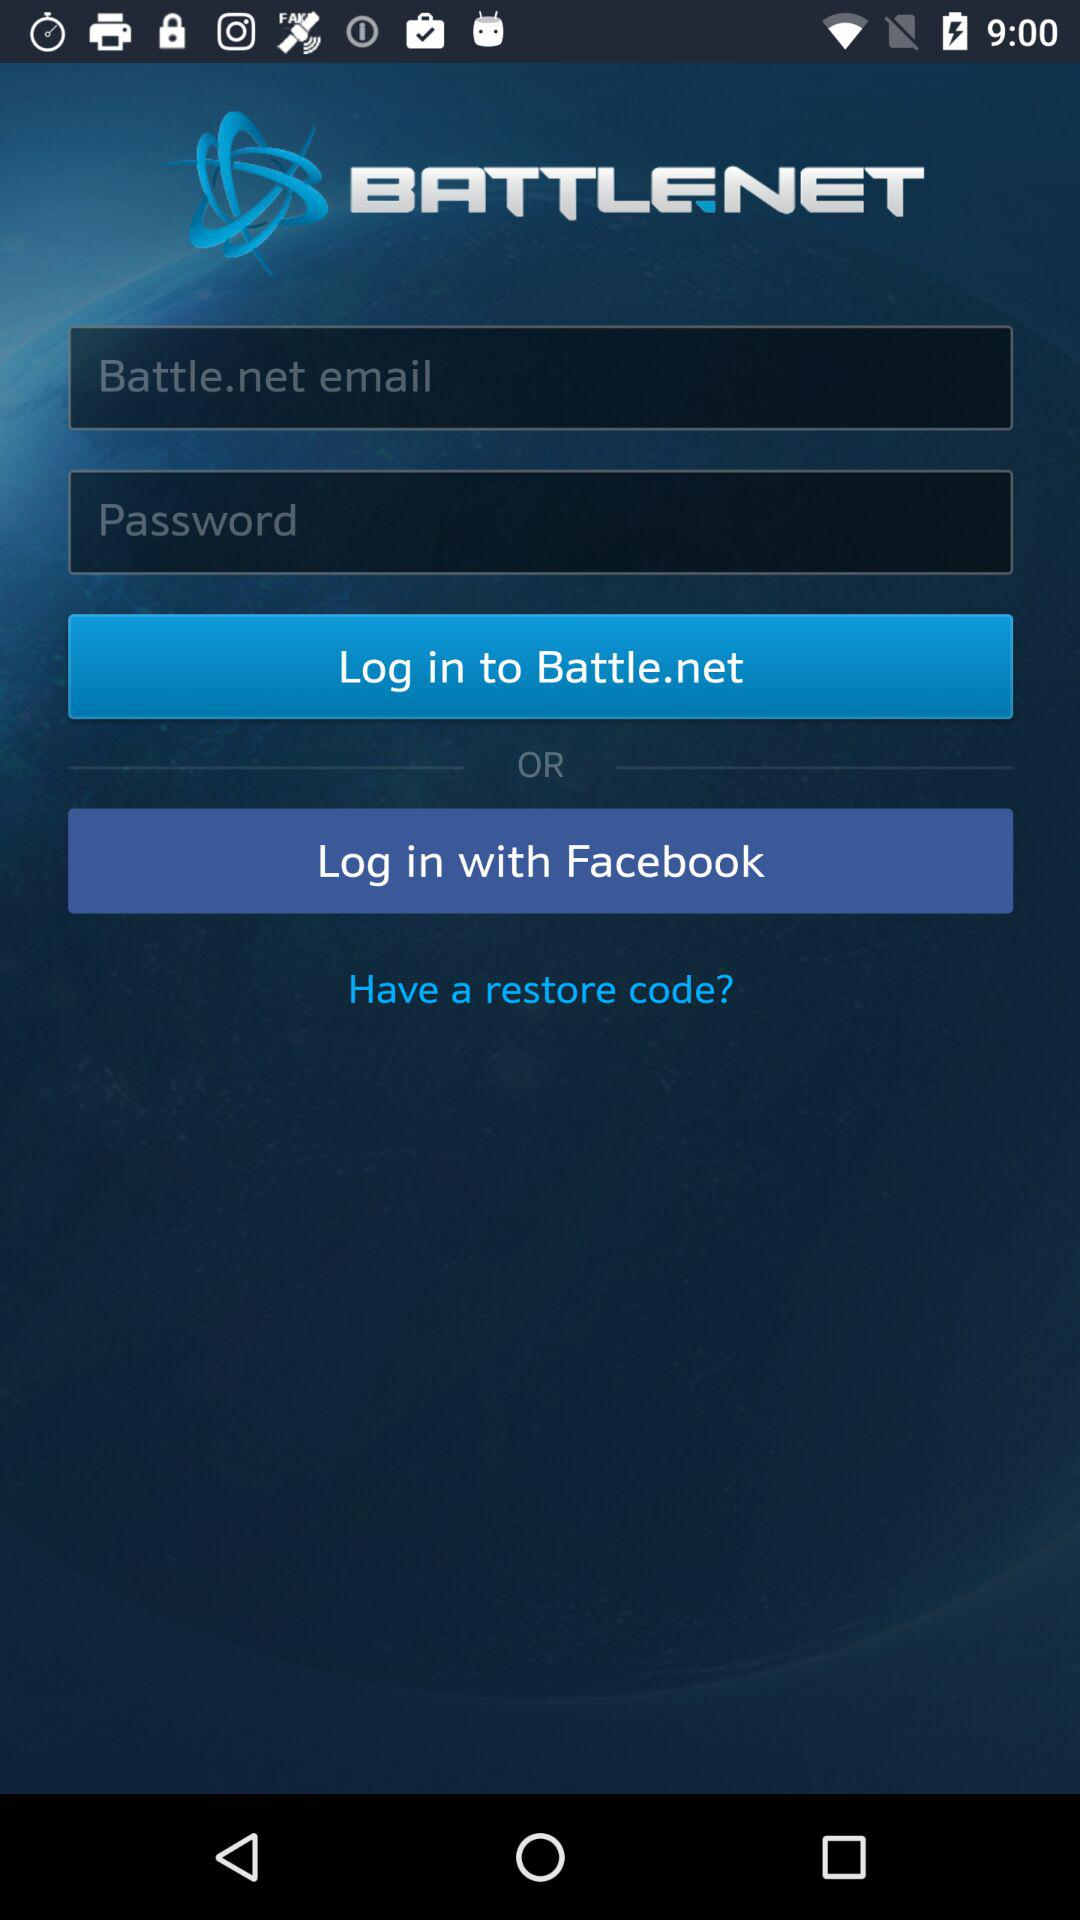To which application can we log in? You can log in to the "Battle.net" application. 